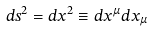<formula> <loc_0><loc_0><loc_500><loc_500>d s ^ { 2 } = d x ^ { 2 } \equiv d x ^ { \mu } d x _ { \mu }</formula> 